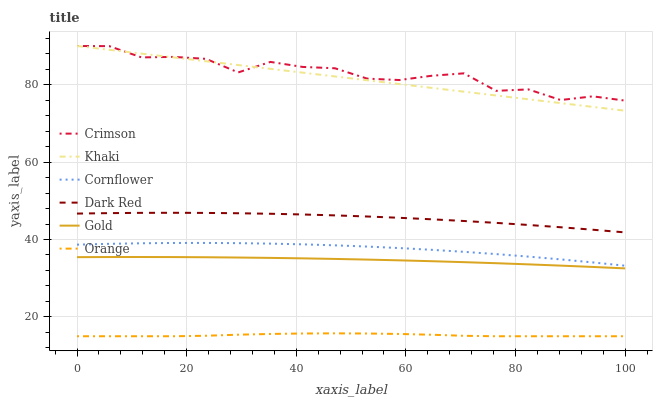Does Khaki have the minimum area under the curve?
Answer yes or no. No. Does Khaki have the maximum area under the curve?
Answer yes or no. No. Is Gold the smoothest?
Answer yes or no. No. Is Gold the roughest?
Answer yes or no. No. Does Khaki have the lowest value?
Answer yes or no. No. Does Gold have the highest value?
Answer yes or no. No. Is Cornflower less than Dark Red?
Answer yes or no. Yes. Is Crimson greater than Orange?
Answer yes or no. Yes. Does Cornflower intersect Dark Red?
Answer yes or no. No. 